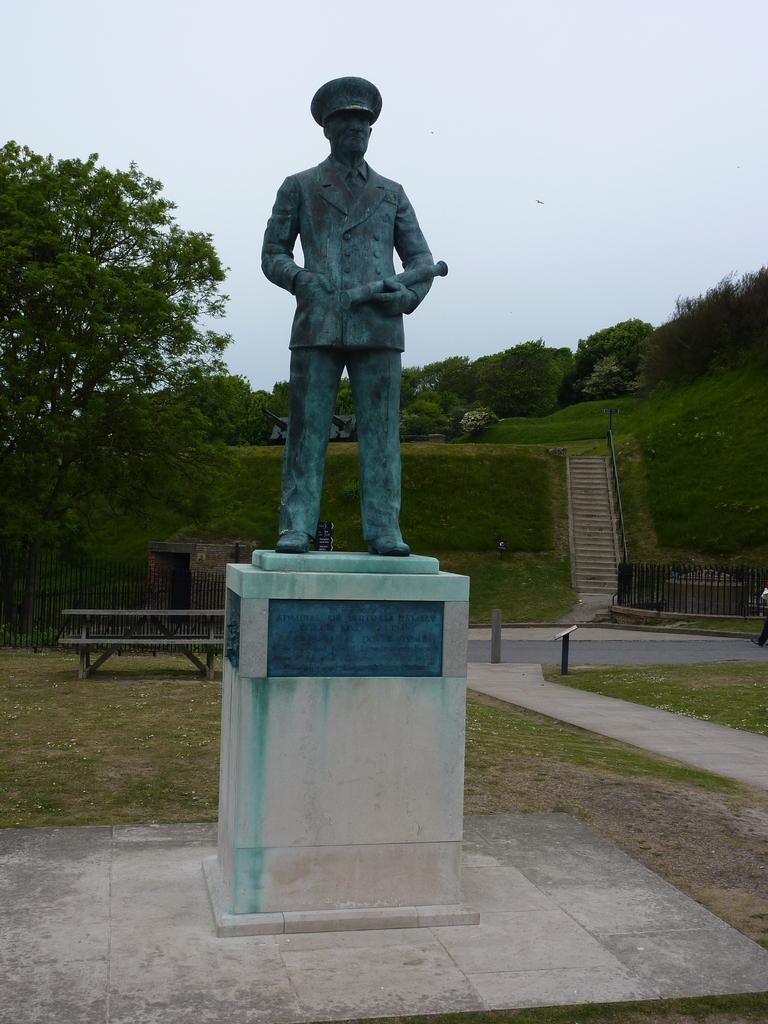What is the main subject of the image? There is a sculpture in the image. What can be seen in the background of the image? There is a fence, a bench, trees, grass, steps, and the sky visible in the background of the image. What type of owl can be seen perched on the sculpture in the image? There is no owl present in the image; the main subject is a sculpture. What is the porter carrying in the image? There is no porter present in the image; the main subject is a sculpture, and the focus is on the background elements. 